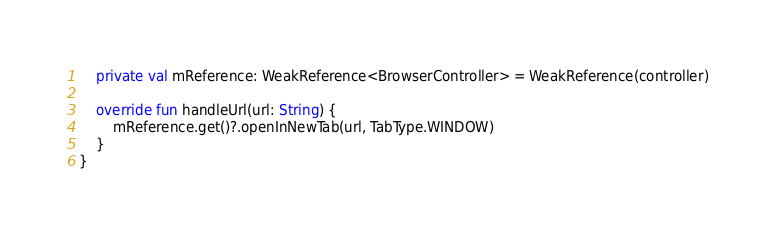<code> <loc_0><loc_0><loc_500><loc_500><_Kotlin_>    private val mReference: WeakReference<BrowserController> = WeakReference(controller)

    override fun handleUrl(url: String) {
        mReference.get()?.openInNewTab(url, TabType.WINDOW)
    }
}
</code> 